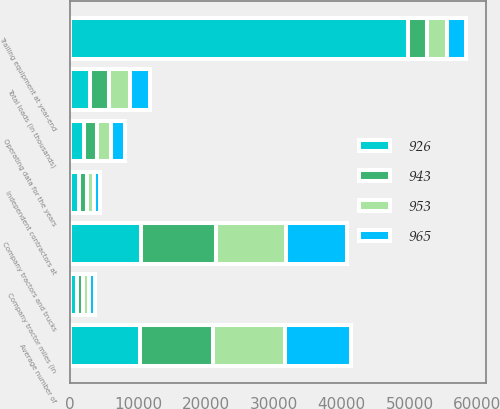<chart> <loc_0><loc_0><loc_500><loc_500><stacked_bar_chart><ecel><fcel>Operating data for the years<fcel>Total loads (in thousands)<fcel>Average number of<fcel>Company tractors and trucks<fcel>Independent contractors at<fcel>Trailing equipment at year-end<fcel>Company tractor miles (in<nl><fcel>965<fcel>2008<fcel>2951<fcel>9688<fcel>9067<fcel>912<fcel>2866<fcel>797<nl><fcel>953<fcel>2007<fcel>3008<fcel>10635<fcel>10308<fcel>1084<fcel>2866<fcel>926<nl><fcel>943<fcel>2006<fcel>2915<fcel>10721<fcel>10961<fcel>1107<fcel>2866<fcel>965<nl><fcel>926<fcel>2005<fcel>2866<fcel>10316<fcel>10480<fcel>1310<fcel>49733<fcel>953<nl></chart> 